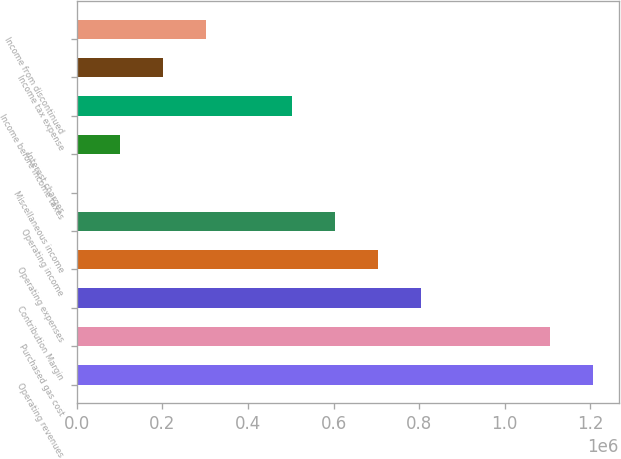Convert chart to OTSL. <chart><loc_0><loc_0><loc_500><loc_500><bar_chart><fcel>Operating revenues<fcel>Purchased gas cost<fcel>Contribution Margin<fcel>Operating expenses<fcel>Operating income<fcel>Miscellaneous income<fcel>Interest charges<fcel>Income before income taxes<fcel>Income tax expense<fcel>Income from discontinued<nl><fcel>1.20609e+06<fcel>1.10559e+06<fcel>804094<fcel>703596<fcel>603098<fcel>109<fcel>100607<fcel>502600<fcel>201105<fcel>301603<nl></chart> 